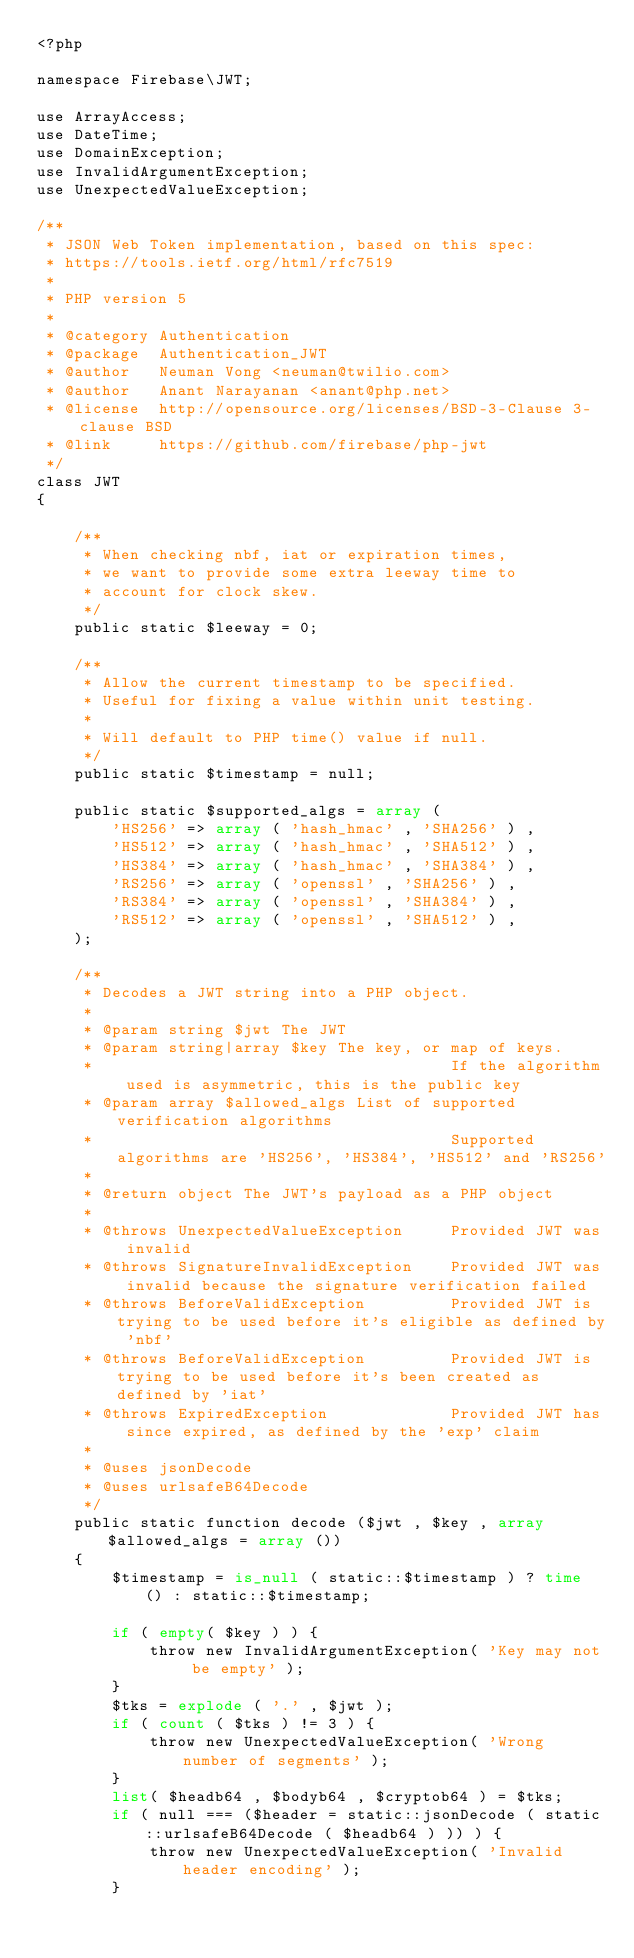Convert code to text. <code><loc_0><loc_0><loc_500><loc_500><_PHP_><?php

namespace Firebase\JWT;

use ArrayAccess;
use DateTime;
use DomainException;
use InvalidArgumentException;
use UnexpectedValueException;

/**
 * JSON Web Token implementation, based on this spec:
 * https://tools.ietf.org/html/rfc7519
 *
 * PHP version 5
 *
 * @category Authentication
 * @package  Authentication_JWT
 * @author   Neuman Vong <neuman@twilio.com>
 * @author   Anant Narayanan <anant@php.net>
 * @license  http://opensource.org/licenses/BSD-3-Clause 3-clause BSD
 * @link     https://github.com/firebase/php-jwt
 */
class JWT
{

    /**
     * When checking nbf, iat or expiration times,
     * we want to provide some extra leeway time to
     * account for clock skew.
     */
    public static $leeway = 0;

    /**
     * Allow the current timestamp to be specified.
     * Useful for fixing a value within unit testing.
     *
     * Will default to PHP time() value if null.
     */
    public static $timestamp = null;

    public static $supported_algs = array (
        'HS256' => array ( 'hash_hmac' , 'SHA256' ) ,
        'HS512' => array ( 'hash_hmac' , 'SHA512' ) ,
        'HS384' => array ( 'hash_hmac' , 'SHA384' ) ,
        'RS256' => array ( 'openssl' , 'SHA256' ) ,
        'RS384' => array ( 'openssl' , 'SHA384' ) ,
        'RS512' => array ( 'openssl' , 'SHA512' ) ,
    );

    /**
     * Decodes a JWT string into a PHP object.
     *
     * @param string $jwt The JWT
     * @param string|array $key The key, or map of keys.
     *                                      If the algorithm used is asymmetric, this is the public key
     * @param array $allowed_algs List of supported verification algorithms
     *                                      Supported algorithms are 'HS256', 'HS384', 'HS512' and 'RS256'
     *
     * @return object The JWT's payload as a PHP object
     *
     * @throws UnexpectedValueException     Provided JWT was invalid
     * @throws SignatureInvalidException    Provided JWT was invalid because the signature verification failed
     * @throws BeforeValidException         Provided JWT is trying to be used before it's eligible as defined by 'nbf'
     * @throws BeforeValidException         Provided JWT is trying to be used before it's been created as defined by 'iat'
     * @throws ExpiredException             Provided JWT has since expired, as defined by the 'exp' claim
     *
     * @uses jsonDecode
     * @uses urlsafeB64Decode
     */
    public static function decode ($jwt , $key , array $allowed_algs = array ())
    {
        $timestamp = is_null ( static::$timestamp ) ? time () : static::$timestamp;

        if ( empty( $key ) ) {
            throw new InvalidArgumentException( 'Key may not be empty' );
        }
        $tks = explode ( '.' , $jwt );
        if ( count ( $tks ) != 3 ) {
            throw new UnexpectedValueException( 'Wrong number of segments' );
        }
        list( $headb64 , $bodyb64 , $cryptob64 ) = $tks;
        if ( null === ($header = static::jsonDecode ( static::urlsafeB64Decode ( $headb64 ) )) ) {
            throw new UnexpectedValueException( 'Invalid header encoding' );
        }</code> 